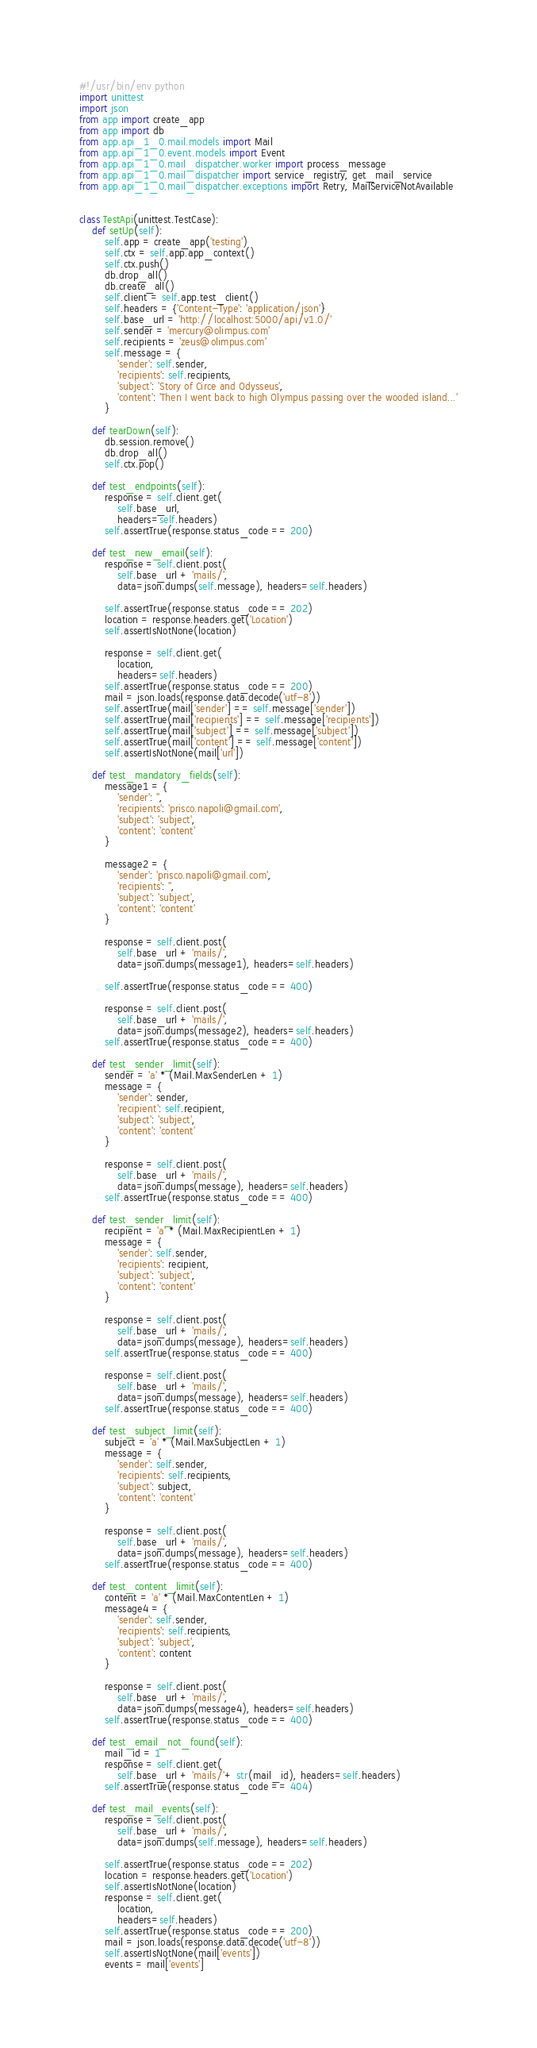<code> <loc_0><loc_0><loc_500><loc_500><_Python_>#!/usr/bin/env python
import unittest
import json
from app import create_app
from app import db
from app.api_1_0.mail.models import Mail
from app.api_1_0.event.models import Event
from app.api_1_0.mail_dispatcher.worker import process_message
from app.api_1_0.mail_dispatcher import service_registry, get_mail_service
from app.api_1_0.mail_dispatcher.exceptions import Retry, MailServiceNotAvailable


class TestApi(unittest.TestCase):
    def setUp(self):
        self.app = create_app('testing')
        self.ctx = self.app.app_context()
        self.ctx.push()
        db.drop_all()
        db.create_all()
        self.client = self.app.test_client()
        self.headers = {'Content-Type': 'application/json'}
        self.base_url = 'http://localhost:5000/api/v1.0/'
        self.sender = 'mercury@olimpus.com'
        self.recipients = 'zeus@olimpus.com'
        self.message = {
            'sender': self.sender,
            'recipients': self.recipients,
            'subject': 'Story of Circe and Odysseus',
            'content': 'Then I went back to high Olympus passing over the wooded island...'
        }

    def tearDown(self):
        db.session.remove()
        db.drop_all()
        self.ctx.pop()

    def test_endpoints(self):
        response = self.client.get(
            self.base_url,
            headers=self.headers)
        self.assertTrue(response.status_code == 200)

    def test_new_email(self):
        response = self.client.post(
            self.base_url + 'mails/',
            data=json.dumps(self.message), headers=self.headers)

        self.assertTrue(response.status_code == 202)
        location = response.headers.get('Location')
        self.assertIsNotNone(location)

        response = self.client.get(
            location,
            headers=self.headers)
        self.assertTrue(response.status_code == 200)
        mail = json.loads(response.data.decode('utf-8'))
        self.assertTrue(mail['sender'] == self.message['sender'])
        self.assertTrue(mail['recipients'] == self.message['recipients'])
        self.assertTrue(mail['subject'] == self.message['subject'])
        self.assertTrue(mail['content'] == self.message['content'])
        self.assertIsNotNone(mail['url'])

    def test_mandatory_fields(self):
        message1 = {
            'sender': '',
            'recipients': 'prisco.napoli@gmail.com',
            'subject': 'subject',
            'content': 'content'
        }

        message2 = {
            'sender': 'prisco.napoli@gmail.com',
            'recipients': '',
            'subject': 'subject',
            'content': 'content'
        }

        response = self.client.post(
            self.base_url + 'mails/',
            data=json.dumps(message1), headers=self.headers)

        self.assertTrue(response.status_code == 400)

        response = self.client.post(
            self.base_url + 'mails/',
            data=json.dumps(message2), headers=self.headers)
        self.assertTrue(response.status_code == 400)

    def test_sender_limit(self):
        sender = 'a' * (Mail.MaxSenderLen + 1)
        message = {
            'sender': sender,
            'recipient': self.recipient,
            'subject': 'subject',
            'content': 'content'
        }

        response = self.client.post(
            self.base_url + 'mails/',
            data=json.dumps(message), headers=self.headers)
        self.assertTrue(response.status_code == 400)

    def test_sender_limit(self):
        recipient = 'a' * (Mail.MaxRecipientLen + 1)
        message = {
            'sender': self.sender,
            'recipients': recipient,
            'subject': 'subject',
            'content': 'content'
        }

        response = self.client.post(
            self.base_url + 'mails/',
            data=json.dumps(message), headers=self.headers)
        self.assertTrue(response.status_code == 400)

        response = self.client.post(
            self.base_url + 'mails/',
            data=json.dumps(message), headers=self.headers)
        self.assertTrue(response.status_code == 400)

    def test_subject_limit(self):
        subject = 'a' * (Mail.MaxSubjectLen + 1)
        message = {
            'sender': self.sender,
            'recipients': self.recipients,
            'subject': subject,
            'content': 'content'
        }

        response = self.client.post(
            self.base_url + 'mails/',
            data=json.dumps(message), headers=self.headers)
        self.assertTrue(response.status_code == 400)

    def test_content_limit(self):
        content = 'a' * (Mail.MaxContentLen + 1)
        message4 = {
            'sender': self.sender,
            'recipients': self.recipients,
            'subject': 'subject',
            'content': content
        }

        response = self.client.post(
            self.base_url + 'mails/',
            data=json.dumps(message4), headers=self.headers)
        self.assertTrue(response.status_code == 400)

    def test_email_not_found(self):
        mail_id = 1
        response = self.client.get(
            self.base_url + 'mails/'+ str(mail_id), headers=self.headers)
        self.assertTrue(response.status_code == 404)

    def test_mail_events(self):
        response = self.client.post(
            self.base_url + 'mails/',
            data=json.dumps(self.message), headers=self.headers)

        self.assertTrue(response.status_code == 202)
        location = response.headers.get('Location')
        self.assertIsNotNone(location)
        response = self.client.get(
            location,
            headers=self.headers)
        self.assertTrue(response.status_code == 200)
        mail = json.loads(response.data.decode('utf-8'))
        self.assertIsNotNone(mail['events'])
        events = mail['events']</code> 